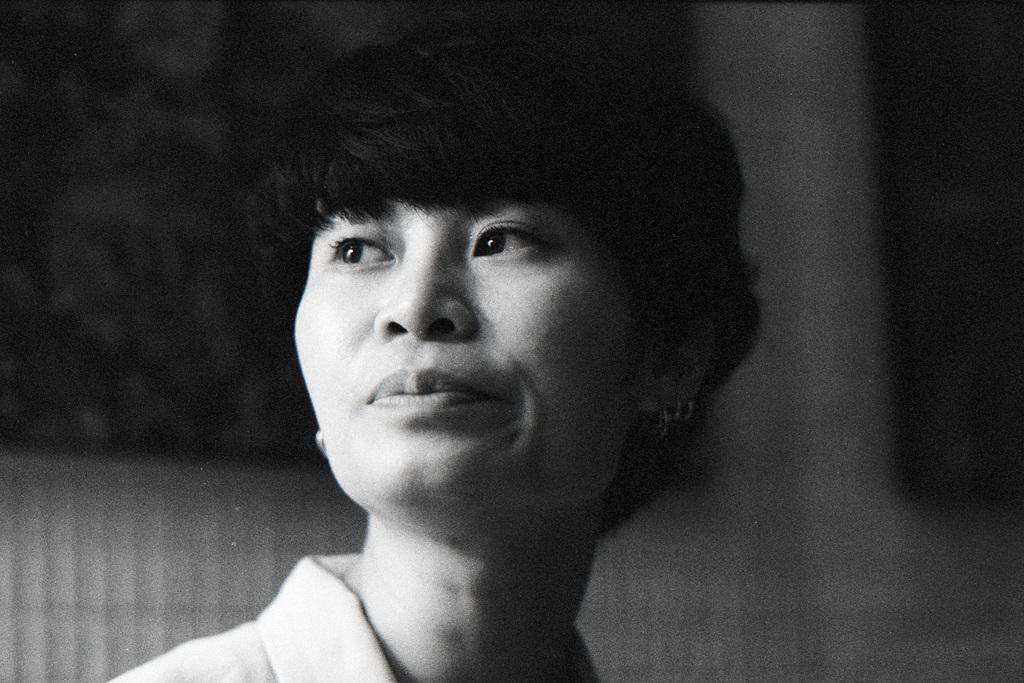What is the color scheme of the image? The image is black and white. Who is present in the image? There is a woman in the image. What direction is the woman looking in? The woman is looking to the left. How would you describe the background of the image? The background of the image is blurred. What type of mine is visible in the background of the image? There is no mine present in the image; it is a black and white photograph featuring a woman looking to the left with a blurred background. 